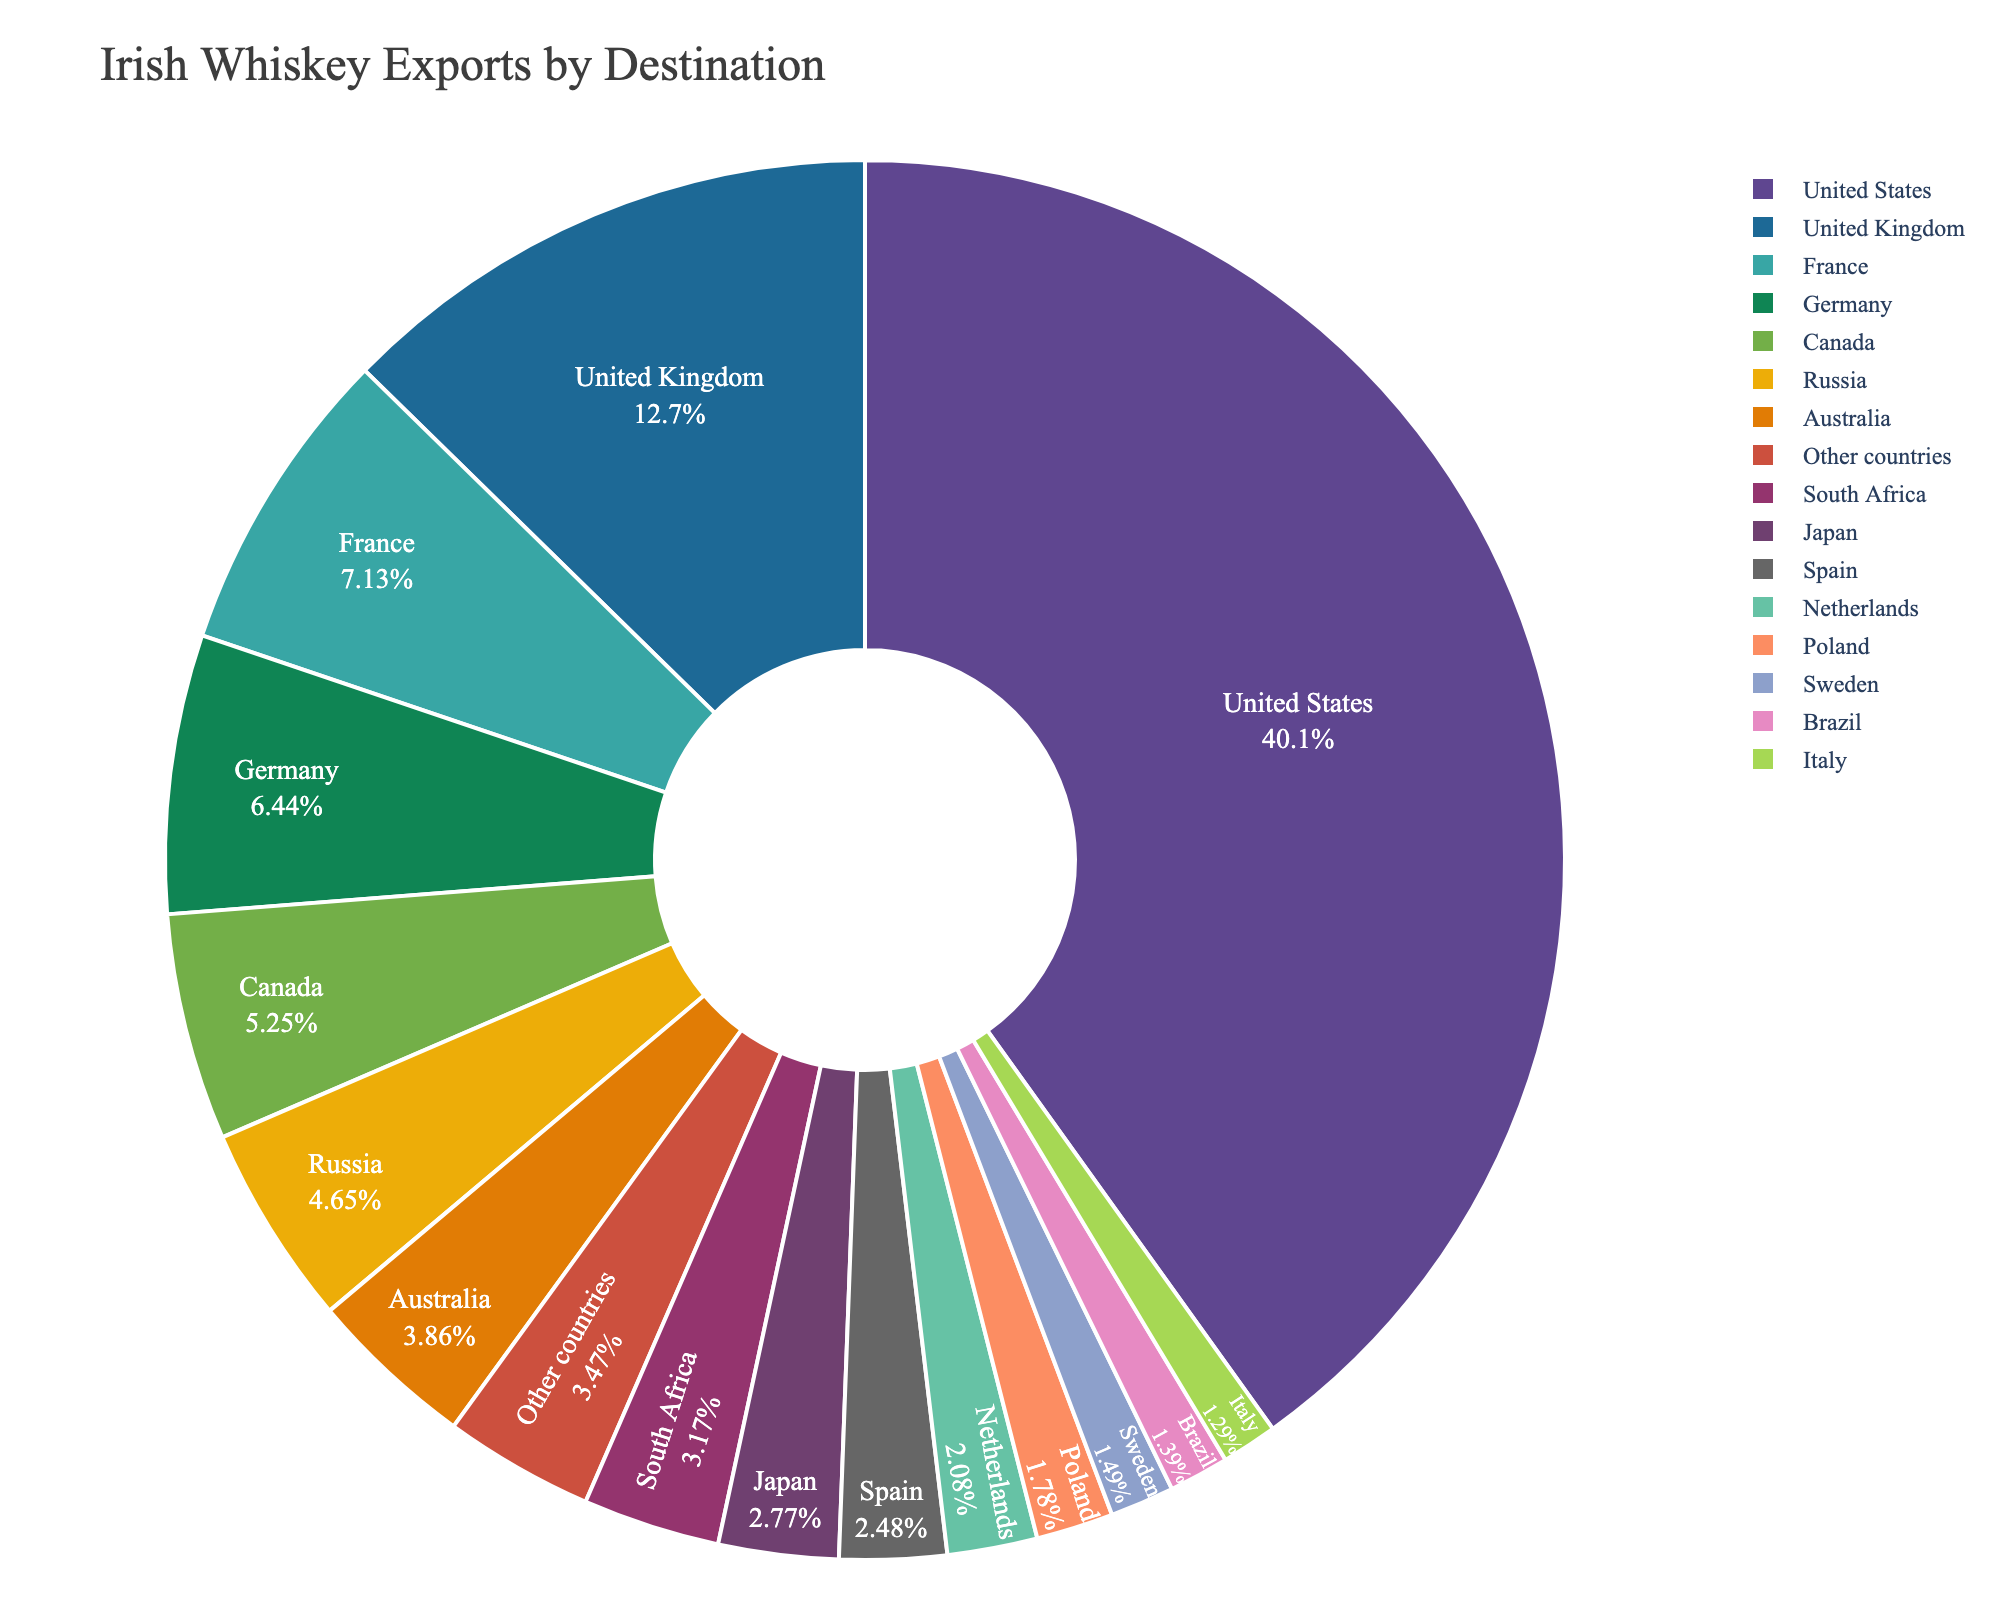Which country has the largest share of Irish whiskey exports? The pie chart shows various countries and their shares in Irish whiskey exports. The United States has the largest portion of the pie chart with 40.5%.
Answer: United States What is the combined market share of France, Germany, and Canada? France has 7.2%, Germany has 6.5%, and Canada has 5.3%. Adding these together gives 7.2 + 6.5 + 5.3 = 19%.
Answer: 19% How much larger is the market share of the United States compared to the United Kingdom? The United States has 40.5% and the United Kingdom has 12.8%. The difference is 40.5 - 12.8 = 27.7%.
Answer: 27.7% Which country has a market share closest to 4%? By examining the chart, Australia has a market share of 3.9%, which is the closest to 4%.
Answer: Australia What is the market share percentage of countries grouped under 'Other countries'? According to the chart, 'Other countries' have a market share of 3.5%.
Answer: 3.5% What is the sum of the market share percentages for countries with shares less than 3%? Japan (2.8%), Spain (2.5%), Netherlands (2.1%), Poland (1.8%), Sweden (1.5%), Brazil (1.4%), and Italy (1.3%) all have shares less than 3%. Adding these together gives 2.8 + 2.5 + 2.1 + 1.8 + 1.5 + 1.4 + 1.3 = 13.4%.
Answer: 13.4% Which country has a smaller market share, South Africa or Australia, and by how much? South Africa has a market share of 3.2% and Australia has 3.9%. The difference is 3.9 - 3.2 = 0.7%. Therefore, South Africa has a smaller market share by 0.7%.
Answer: South Africa, 0.7% What is the market share percentage difference between the smallest and largest markets in the chart? The smallest market is Italy with 1.3% and the largest is the United States with 40.5%. The difference is 40.5 - 1.3 = 39.2%.
Answer: 39.2% What percentage of the market do the top three countries combined account for? The top three countries are the United States (40.5%), United Kingdom (12.8%), and France (7.2%). Adding their percentages together gives 40.5 + 12.8 + 7.2 = 60.5%.
Answer: 60.5% Which countries have a market share between 1% and 5%? According to the chart, the countries with market shares between 1% and 5% are Canada (5.3%), Russia (4.7%), Australia (3.9%), South Africa (3.2%), Japan (2.8%), Spain (2.5%), Netherlands (2.1%), Poland (1.8%), Sweden (1.5%), Brazil (1.4%), and Italy (1.3%).
Answer: Canada, Russia, Australia, South Africa, Japan, Spain, Netherlands, Poland, Sweden, Brazil, Italy 